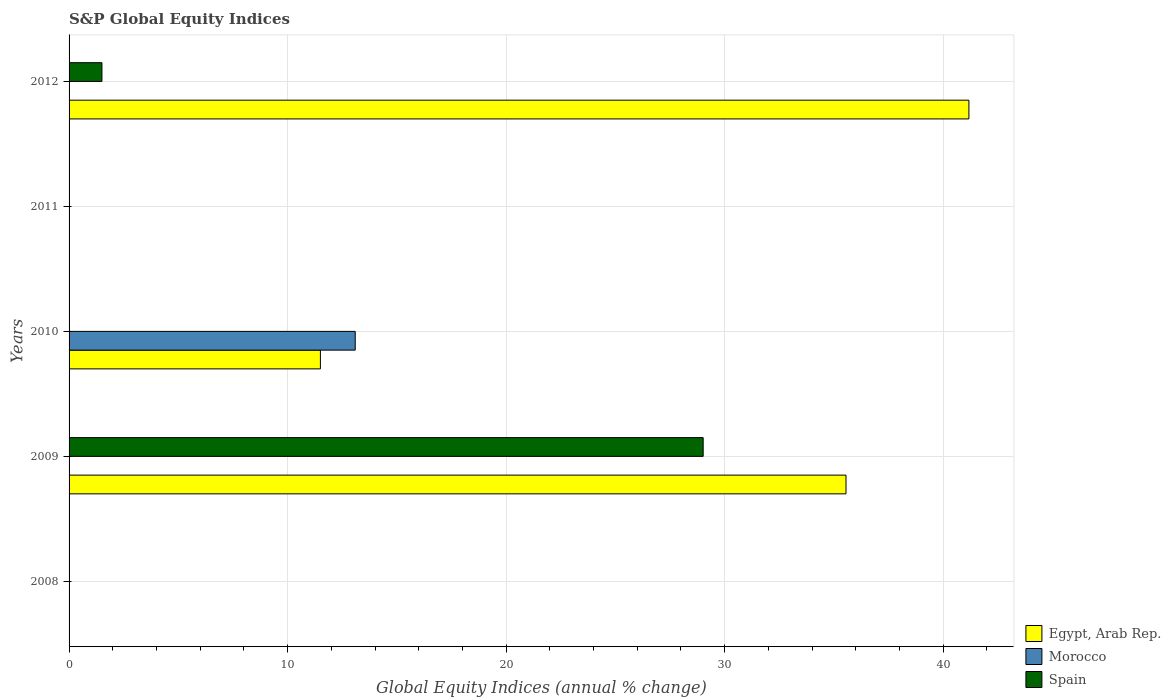How many different coloured bars are there?
Offer a terse response. 3. Are the number of bars on each tick of the Y-axis equal?
Provide a short and direct response. No. What is the label of the 5th group of bars from the top?
Offer a terse response. 2008. In how many cases, is the number of bars for a given year not equal to the number of legend labels?
Offer a very short reply. 5. What is the global equity indices in Spain in 2009?
Provide a short and direct response. 29.02. Across all years, what is the maximum global equity indices in Morocco?
Give a very brief answer. 13.1. What is the total global equity indices in Egypt, Arab Rep. in the graph?
Offer a terse response. 88.23. What is the difference between the global equity indices in Egypt, Arab Rep. in 2010 and that in 2012?
Give a very brief answer. -29.68. What is the difference between the global equity indices in Egypt, Arab Rep. in 2011 and the global equity indices in Spain in 2008?
Give a very brief answer. 0. What is the average global equity indices in Morocco per year?
Your answer should be compact. 2.62. In the year 2012, what is the difference between the global equity indices in Egypt, Arab Rep. and global equity indices in Spain?
Your answer should be compact. 39.67. In how many years, is the global equity indices in Morocco greater than 26 %?
Offer a terse response. 0. What is the difference between the highest and the second highest global equity indices in Egypt, Arab Rep.?
Offer a very short reply. 5.62. What is the difference between the highest and the lowest global equity indices in Egypt, Arab Rep.?
Keep it short and to the point. 41.18. In how many years, is the global equity indices in Spain greater than the average global equity indices in Spain taken over all years?
Ensure brevity in your answer.  1. How many bars are there?
Your response must be concise. 6. Are all the bars in the graph horizontal?
Provide a succinct answer. Yes. How many years are there in the graph?
Your response must be concise. 5. Does the graph contain grids?
Your response must be concise. Yes. How many legend labels are there?
Your answer should be very brief. 3. How are the legend labels stacked?
Offer a very short reply. Vertical. What is the title of the graph?
Offer a very short reply. S&P Global Equity Indices. What is the label or title of the X-axis?
Provide a succinct answer. Global Equity Indices (annual % change). What is the Global Equity Indices (annual % change) of Egypt, Arab Rep. in 2009?
Provide a succinct answer. 35.55. What is the Global Equity Indices (annual % change) of Spain in 2009?
Give a very brief answer. 29.02. What is the Global Equity Indices (annual % change) of Egypt, Arab Rep. in 2010?
Your answer should be compact. 11.5. What is the Global Equity Indices (annual % change) of Morocco in 2010?
Your answer should be compact. 13.1. What is the Global Equity Indices (annual % change) in Spain in 2010?
Keep it short and to the point. 0. What is the Global Equity Indices (annual % change) of Spain in 2011?
Keep it short and to the point. 0. What is the Global Equity Indices (annual % change) in Egypt, Arab Rep. in 2012?
Your answer should be compact. 41.18. What is the Global Equity Indices (annual % change) of Spain in 2012?
Your answer should be compact. 1.5. Across all years, what is the maximum Global Equity Indices (annual % change) in Egypt, Arab Rep.?
Provide a succinct answer. 41.18. Across all years, what is the maximum Global Equity Indices (annual % change) of Morocco?
Provide a succinct answer. 13.1. Across all years, what is the maximum Global Equity Indices (annual % change) in Spain?
Offer a very short reply. 29.02. Across all years, what is the minimum Global Equity Indices (annual % change) of Egypt, Arab Rep.?
Ensure brevity in your answer.  0. What is the total Global Equity Indices (annual % change) of Egypt, Arab Rep. in the graph?
Your response must be concise. 88.23. What is the total Global Equity Indices (annual % change) of Morocco in the graph?
Your answer should be compact. 13.1. What is the total Global Equity Indices (annual % change) in Spain in the graph?
Ensure brevity in your answer.  30.52. What is the difference between the Global Equity Indices (annual % change) in Egypt, Arab Rep. in 2009 and that in 2010?
Provide a succinct answer. 24.05. What is the difference between the Global Equity Indices (annual % change) of Egypt, Arab Rep. in 2009 and that in 2012?
Offer a very short reply. -5.62. What is the difference between the Global Equity Indices (annual % change) in Spain in 2009 and that in 2012?
Keep it short and to the point. 27.51. What is the difference between the Global Equity Indices (annual % change) in Egypt, Arab Rep. in 2010 and that in 2012?
Your answer should be compact. -29.68. What is the difference between the Global Equity Indices (annual % change) in Egypt, Arab Rep. in 2009 and the Global Equity Indices (annual % change) in Morocco in 2010?
Your answer should be very brief. 22.46. What is the difference between the Global Equity Indices (annual % change) of Egypt, Arab Rep. in 2009 and the Global Equity Indices (annual % change) of Spain in 2012?
Your answer should be compact. 34.05. What is the difference between the Global Equity Indices (annual % change) in Egypt, Arab Rep. in 2010 and the Global Equity Indices (annual % change) in Spain in 2012?
Offer a very short reply. 10. What is the difference between the Global Equity Indices (annual % change) of Morocco in 2010 and the Global Equity Indices (annual % change) of Spain in 2012?
Provide a succinct answer. 11.59. What is the average Global Equity Indices (annual % change) in Egypt, Arab Rep. per year?
Your response must be concise. 17.65. What is the average Global Equity Indices (annual % change) of Morocco per year?
Provide a short and direct response. 2.62. What is the average Global Equity Indices (annual % change) in Spain per year?
Provide a short and direct response. 6.1. In the year 2009, what is the difference between the Global Equity Indices (annual % change) of Egypt, Arab Rep. and Global Equity Indices (annual % change) of Spain?
Keep it short and to the point. 6.54. In the year 2010, what is the difference between the Global Equity Indices (annual % change) of Egypt, Arab Rep. and Global Equity Indices (annual % change) of Morocco?
Your answer should be compact. -1.59. In the year 2012, what is the difference between the Global Equity Indices (annual % change) in Egypt, Arab Rep. and Global Equity Indices (annual % change) in Spain?
Make the answer very short. 39.67. What is the ratio of the Global Equity Indices (annual % change) of Egypt, Arab Rep. in 2009 to that in 2010?
Your answer should be compact. 3.09. What is the ratio of the Global Equity Indices (annual % change) of Egypt, Arab Rep. in 2009 to that in 2012?
Your response must be concise. 0.86. What is the ratio of the Global Equity Indices (annual % change) in Spain in 2009 to that in 2012?
Provide a short and direct response. 19.3. What is the ratio of the Global Equity Indices (annual % change) in Egypt, Arab Rep. in 2010 to that in 2012?
Provide a succinct answer. 0.28. What is the difference between the highest and the second highest Global Equity Indices (annual % change) of Egypt, Arab Rep.?
Your answer should be very brief. 5.62. What is the difference between the highest and the lowest Global Equity Indices (annual % change) of Egypt, Arab Rep.?
Give a very brief answer. 41.18. What is the difference between the highest and the lowest Global Equity Indices (annual % change) of Morocco?
Offer a very short reply. 13.1. What is the difference between the highest and the lowest Global Equity Indices (annual % change) in Spain?
Your response must be concise. 29.02. 